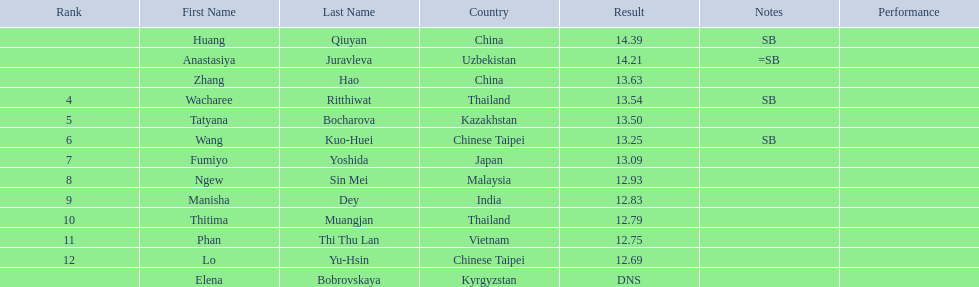Which country came in first? China. 